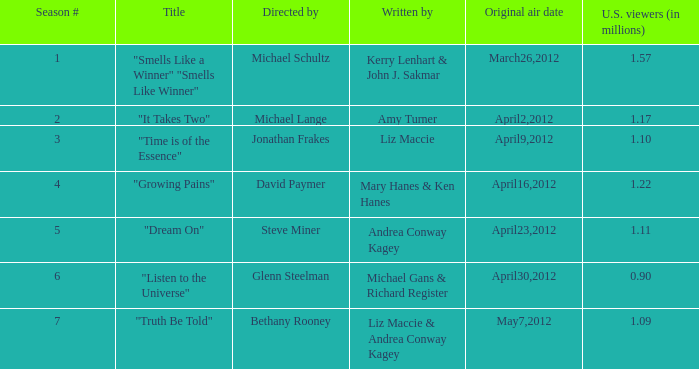When was the first broadcast of the episode titled "Truth Be Told"? May7,2012. 